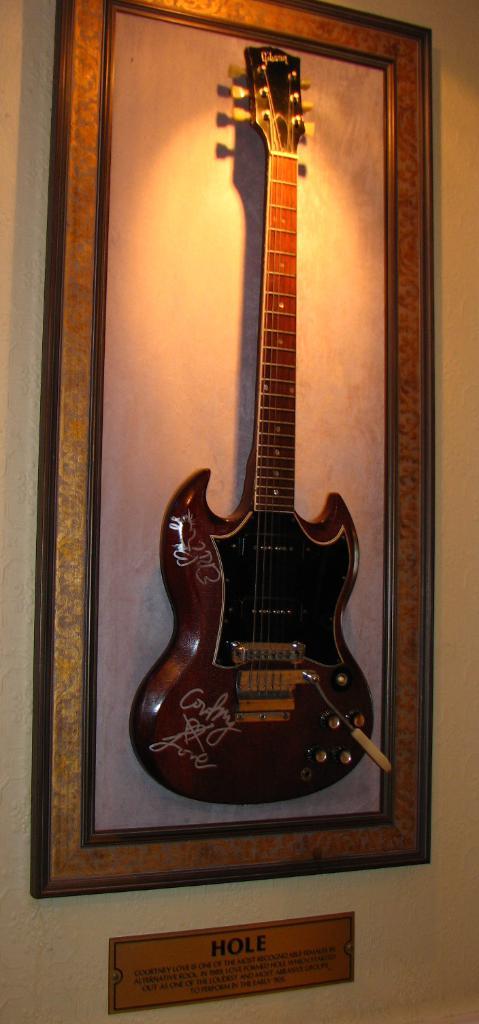Who signed the guitar?
Provide a short and direct response. Hole. What band does this belong to?
Provide a succinct answer. Hole. 